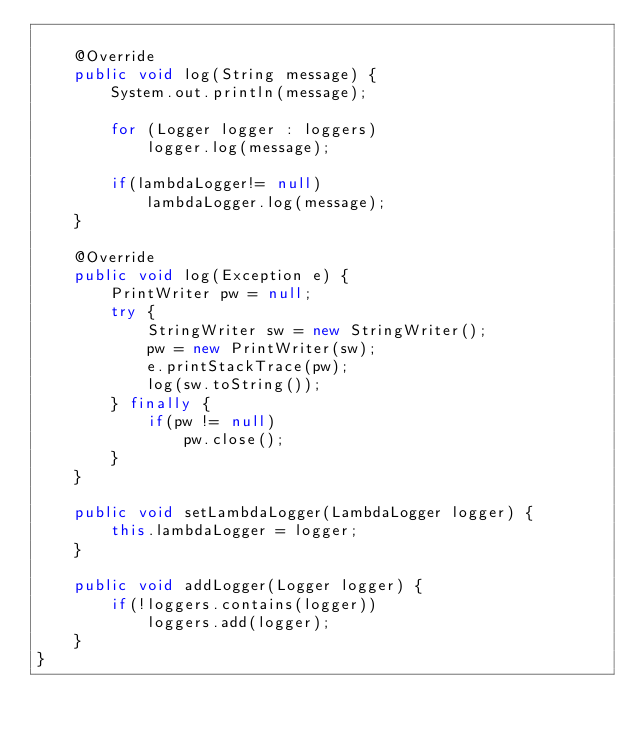<code> <loc_0><loc_0><loc_500><loc_500><_Java_>
    @Override
    public void log(String message) {
        System.out.println(message);

        for (Logger logger : loggers)
            logger.log(message);

        if(lambdaLogger!= null)
            lambdaLogger.log(message);
    }

    @Override
    public void log(Exception e) {
        PrintWriter pw = null;
        try {
            StringWriter sw = new StringWriter();
            pw = new PrintWriter(sw);
            e.printStackTrace(pw);
            log(sw.toString());
        } finally {
            if(pw != null)
                pw.close();
        }
    }

    public void setLambdaLogger(LambdaLogger logger) {
        this.lambdaLogger = logger;
    }

    public void addLogger(Logger logger) {
        if(!loggers.contains(logger))
            loggers.add(logger);
    }
}
</code> 